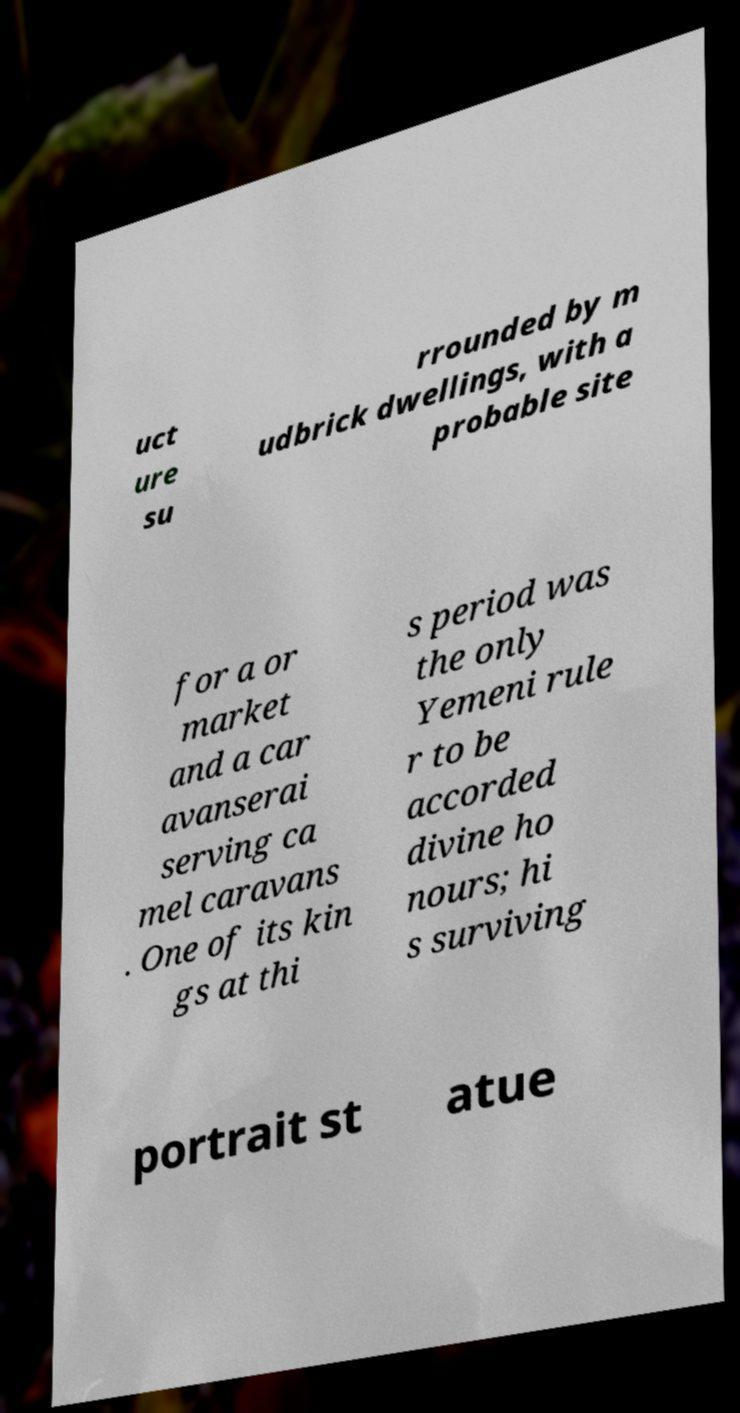Could you extract and type out the text from this image? uct ure su rrounded by m udbrick dwellings, with a probable site for a or market and a car avanserai serving ca mel caravans . One of its kin gs at thi s period was the only Yemeni rule r to be accorded divine ho nours; hi s surviving portrait st atue 